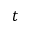<formula> <loc_0><loc_0><loc_500><loc_500>t</formula> 